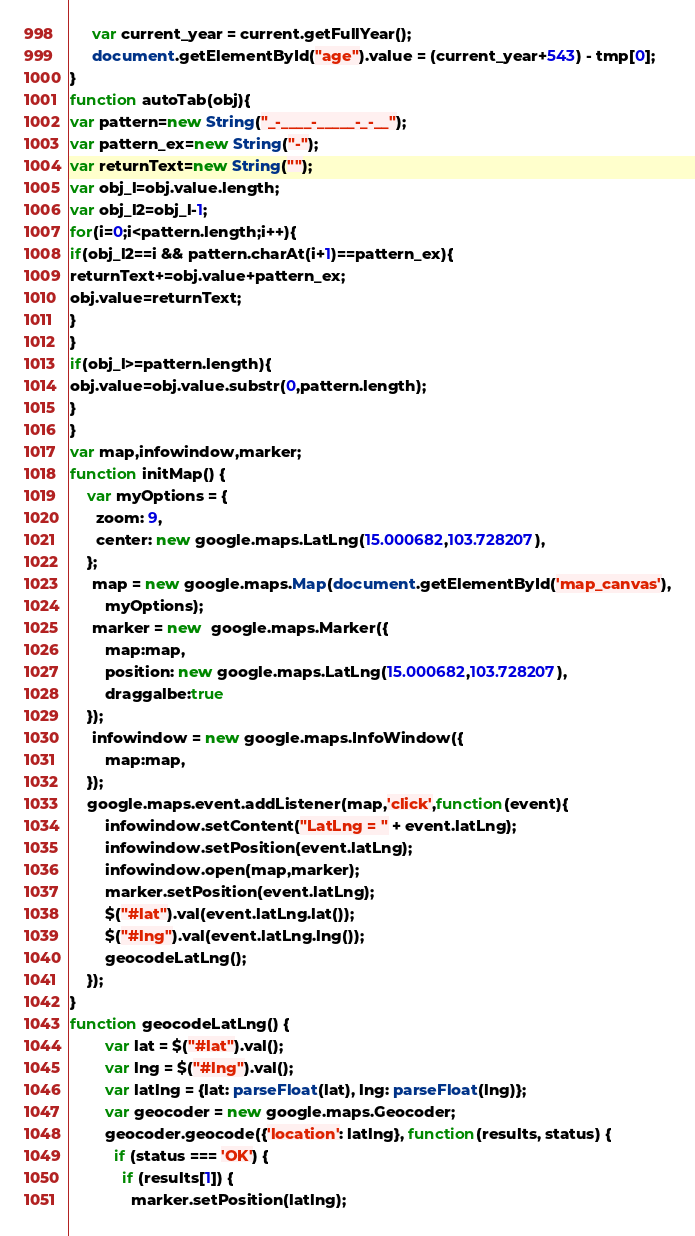<code> <loc_0><loc_0><loc_500><loc_500><_JavaScript_>     var current_year = current.getFullYear();
     document.getElementById("age").value = (current_year+543) - tmp[0];
}
function autoTab(obj){ 
var pattern=new String("_-____-_____-_-__"); 
var pattern_ex=new String("-"); 
var returnText=new String(""); 
var obj_l=obj.value.length; 
var obj_l2=obj_l-1; 
for(i=0;i<pattern.length;i++){ 
if(obj_l2==i && pattern.charAt(i+1)==pattern_ex){ 
returnText+=obj.value+pattern_ex; 
obj.value=returnText; 
} 
} 
if(obj_l>=pattern.length){ 
obj.value=obj.value.substr(0,pattern.length); 
} 
} 
var map,infowindow,marker;
function initMap() { 
	var myOptions = {
	  zoom: 9,
	  center: new google.maps.LatLng(15.000682,103.728207),
	};
	 map = new google.maps.Map(document.getElementById('map_canvas'),
		myOptions);
	 marker = new  google.maps.Marker({
		map:map,
		position: new google.maps.LatLng(15.000682,103.728207),
		draggalbe:true
	});
	 infowindow = new google.maps.InfoWindow({
		map:map,
	});
	google.maps.event.addListener(map,'click',function(event){		
		infowindow.setContent("LatLng = " + event.latLng);
		infowindow.setPosition(event.latLng);
		infowindow.open(map,marker);
		marker.setPosition(event.latLng);
		$("#lat").val(event.latLng.lat());
		$("#lng").val(event.latLng.lng());
		geocodeLatLng();
	});	
}
function geocodeLatLng() {
		var lat = $("#lat").val();
		var lng = $("#lng").val();
        var latlng = {lat: parseFloat(lat), lng: parseFloat(lng)};
		var geocoder = new google.maps.Geocoder;
        geocoder.geocode({'location': latlng}, function(results, status) {
          if (status === 'OK') {
            if (results[1]) {             
			  marker.setPosition(latlng);</code> 